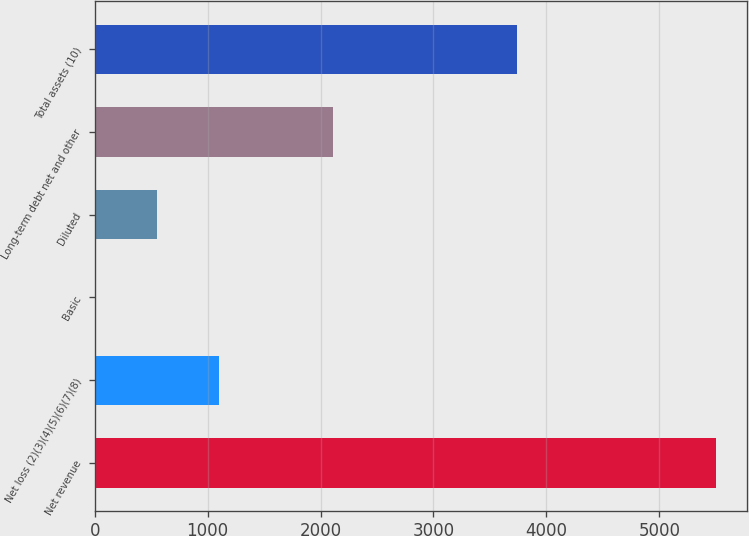Convert chart. <chart><loc_0><loc_0><loc_500><loc_500><bar_chart><fcel>Net revenue<fcel>Net loss (2)(3)(4)(5)(6)(7)(8)<fcel>Basic<fcel>Diluted<fcel>Long-term debt net and other<fcel>Total assets (10)<nl><fcel>5506<fcel>1101.63<fcel>0.53<fcel>551.08<fcel>2110<fcel>3737<nl></chart> 